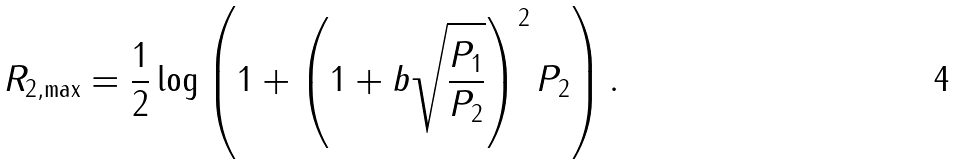Convert formula to latex. <formula><loc_0><loc_0><loc_500><loc_500>R _ { 2 , \max } = \frac { 1 } { 2 } \log \left ( 1 + \left ( 1 + b \sqrt { \frac { P _ { 1 } } { P _ { 2 } } } \right ) ^ { 2 } P _ { 2 } \right ) .</formula> 